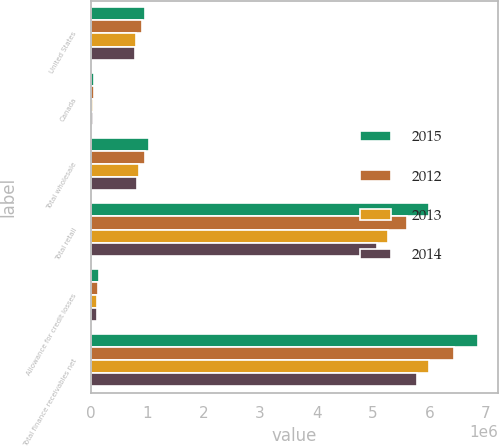<chart> <loc_0><loc_0><loc_500><loc_500><stacked_bar_chart><ecel><fcel>United States<fcel>Canada<fcel>Total wholesale<fcel>Total retail<fcel>Allowance for credit losses<fcel>Total finance receivables net<nl><fcel>2015<fcel>965379<fcel>58481<fcel>1.02386e+06<fcel>5.99147e+06<fcel>147178<fcel>6.86815e+06<nl><fcel>2012<fcel>903380<fcel>48941<fcel>952321<fcel>5.60792e+06<fcel>127364<fcel>6.43288e+06<nl><fcel>2013<fcel>800491<fcel>44721<fcel>845212<fcel>5.26504e+06<fcel>110693<fcel>5.99956e+06<nl><fcel>2014<fcel>776633<fcel>39771<fcel>816404<fcel>5.07312e+06<fcel>107667<fcel>5.78185e+06<nl></chart> 